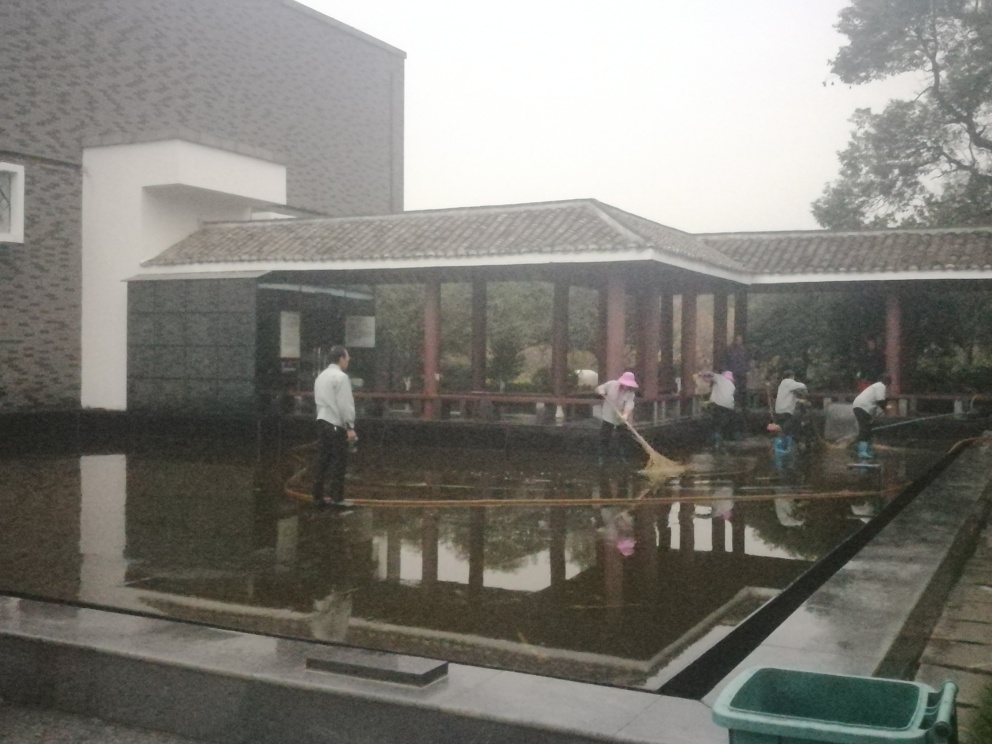How is the background of the image?
A. Focused
B. Blurry.
C. Clear
D. Detailed
Answer with the option's letter from the given choices directly.
 B. 